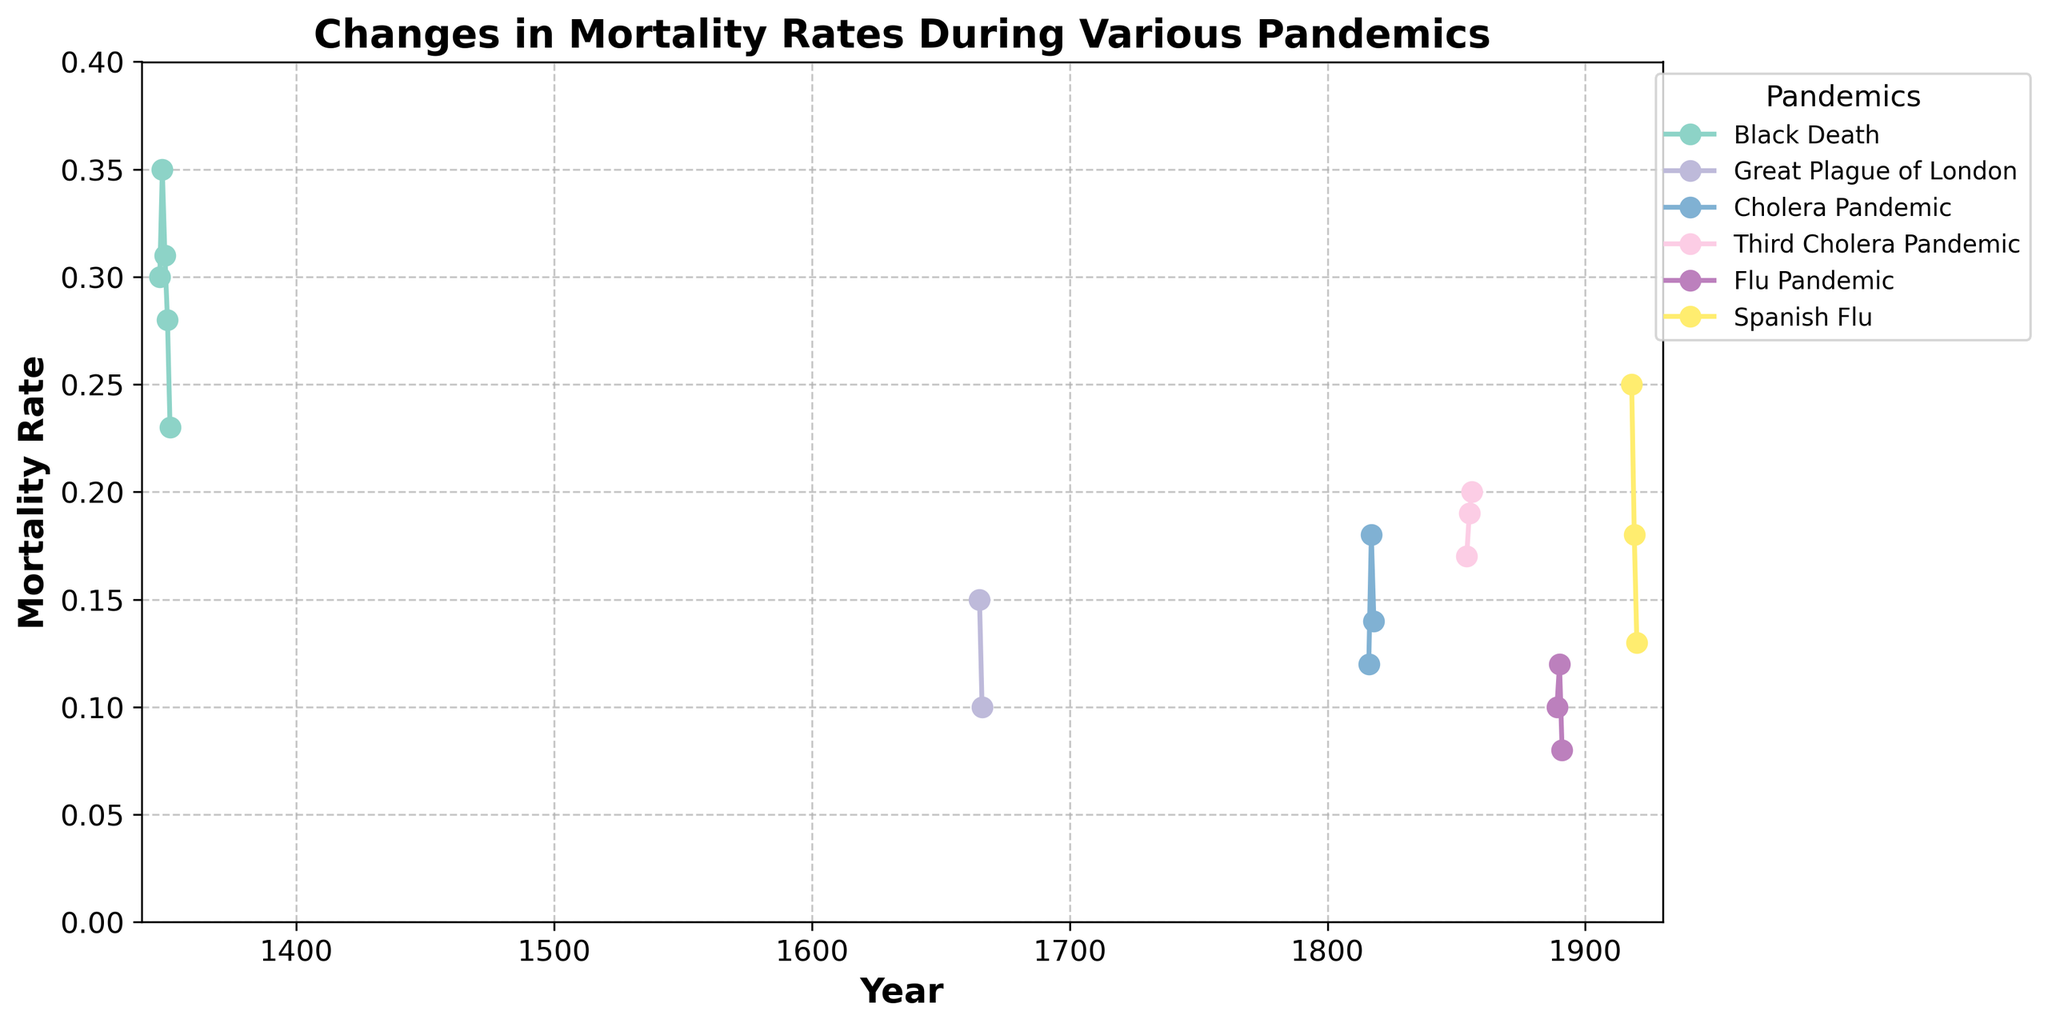What is the title of the figure? The title of the figure is located at the top and summarizes the content shown in the plot. Here, it states the purpose and scope of the time series data.
Answer: Changes in Mortality Rates During Various Pandemics How many pandemics are represented in the figure? The legend on the right-hand side of the figure lists all the pandemics being displayed. Each pandemic has a unique color. By counting the entries in the legend, we can determine the number of pandemics.
Answer: 5 During which years does the plot show the starkest decline in mortality rate for a single pandemic, and which pandemic is it? By examining the plot, look for the steepest downward slope within a single curve. This indicates the most significant decline. Identify the years and the specific pandemic corresponding to that curve.
Answer: 1918-1919, Spanish Flu What pandemic had the highest mortality rate at its peak, and what was that rate? Focus on the maximum points for each curve. The highest point among all the curves represents the peak mortality for the respective pandemic. Identify the peak value and corresponding pandemic.
Answer: Black Death, 0.35 Which pandemic showed a steady increase in mortality rate over consecutive years, and what were those years? Identify any curve that continuously ascends over the years without any drop. Trace this increase and note the years it covers.
Answer: Third Cholera Pandemic, 1854-1856 What was the mortality rate in 1666 during the Great Plague of London, and how does it compare to its rate in 1665? Locate the points on the curve for the Great Plague of London corresponding to years 1665 and 1666. Compare the values to see how the mortality rate changed.
Answer: 0.10 in 1666, which is lower than 0.15 in 1665 Which pandemic had the shortest duration as represented in the figure? To determine the shortest duration, find the curves that start and end within the smallest range of years and note which pandemic it represents.
Answer: Great Plague of London Between the years 1816 and 1818, how did the mortality rate change for the Cholera Pandemic? Examine the curve corresponding to the Cholera Pandemic for the years 1816, 1817, and 1818. Note the mortality rates for these years and describe the trend.
Answer: Increased from 0.12 to 0.18, then decreased to 0.14 How does the final mortality rate for the Third Cholera Pandemic in 1856 compare to the initial rate in 1854? Observe the mortality rates at the start (1854) and the end (1856) of the Third Cholera Pandemic. Compare these two values directly.
Answer: 0.20 in 1856, which is higher than 0.17 in 1854 